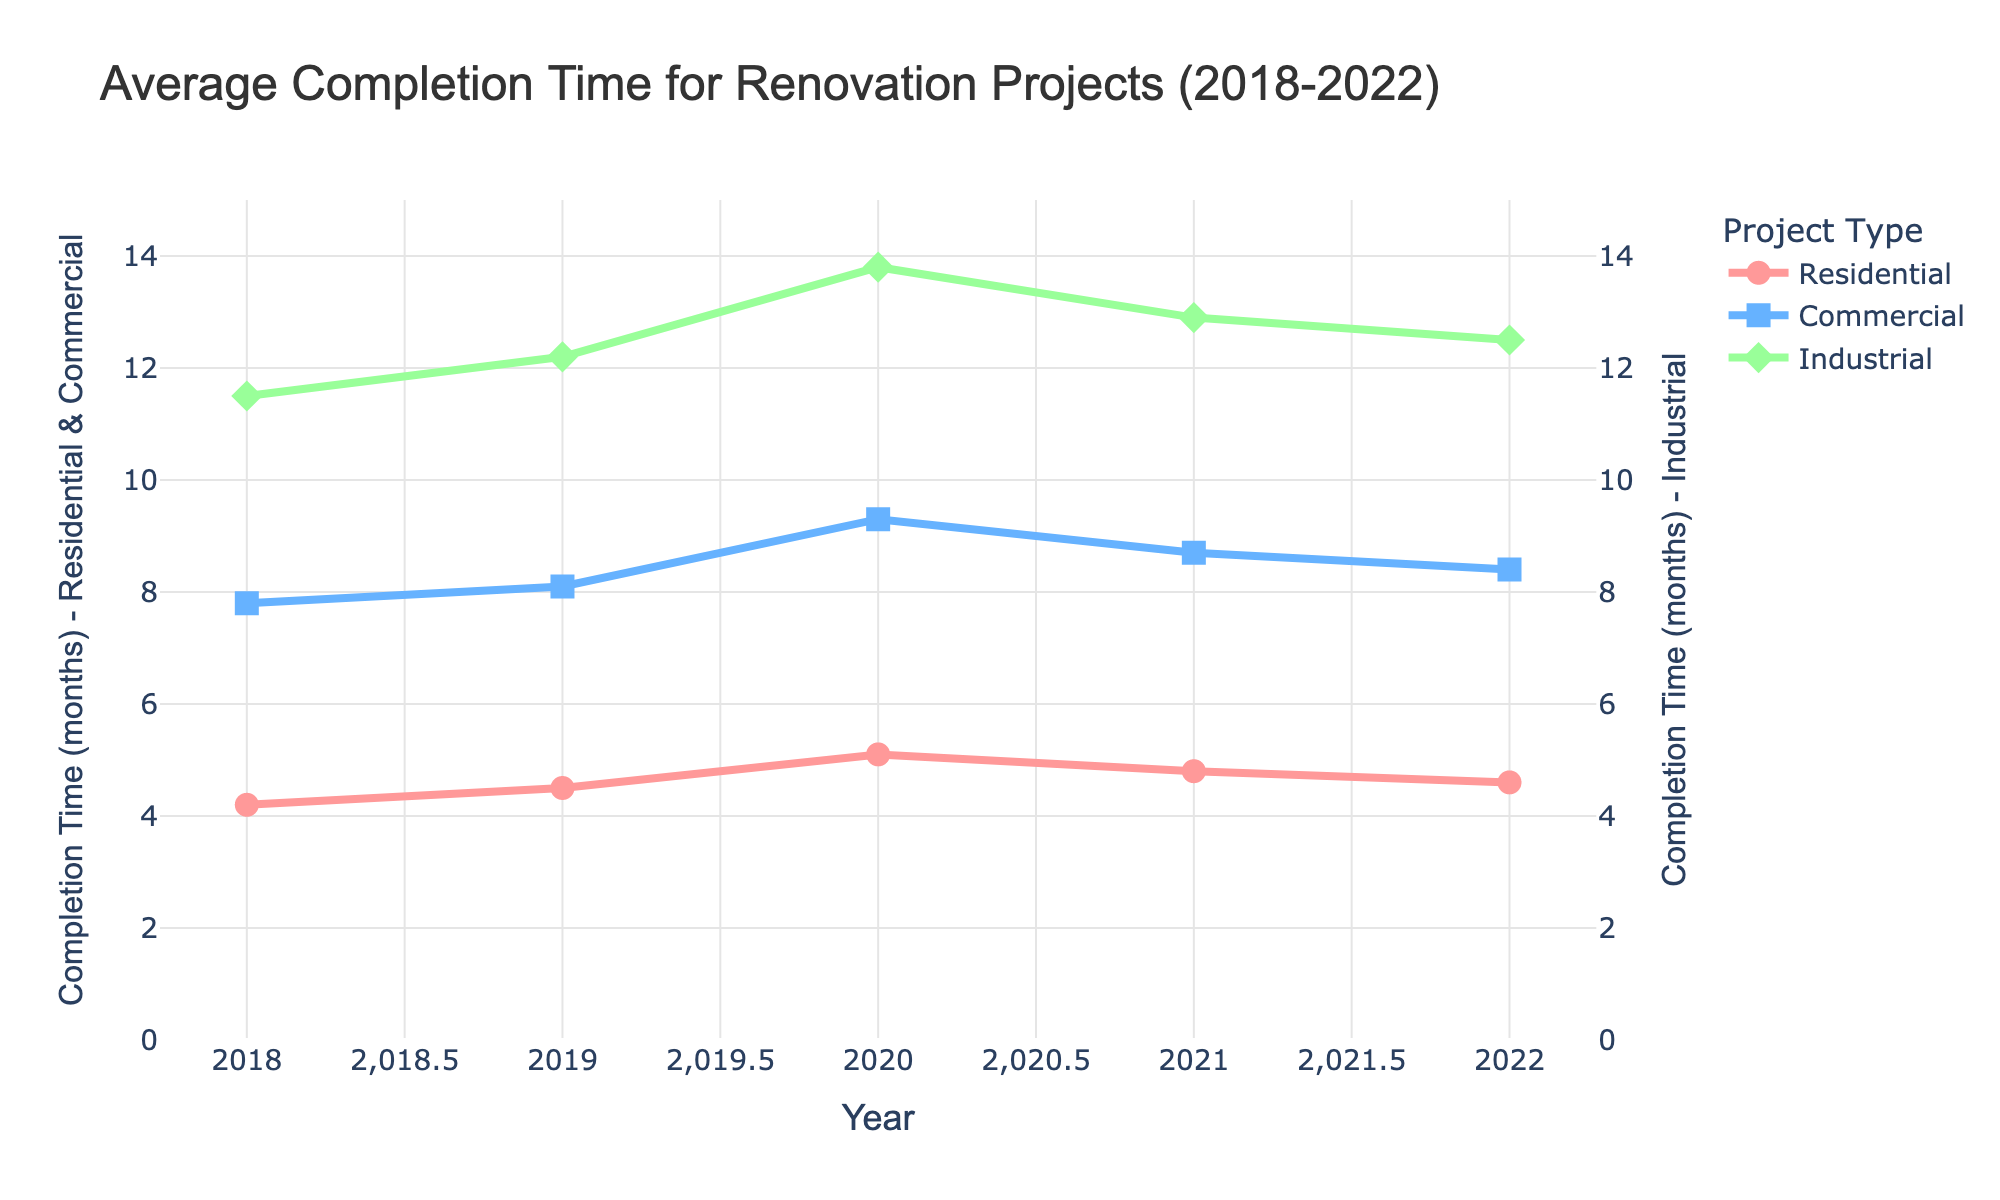What was the average completion time for residential projects in 2020? The residential completion time for 2020 is indicated by the red line. The value for 2020 is 5.1 months.
Answer: 5.1 months Which year had the highest completion time for commercial projects? The blue line represents commercial projects. The peak value is in 2020 with a completion time of 9.3 months.
Answer: 2020 Did the completion time for industrial projects increase or decrease from 2019 to 2020? The green line represents industrial projects. In 2019, the time is 12.2 months, and in 2020, it increased to 13.8 months.
Answer: Increase How did the completion time for residential projects change from 2020 to 2022, and by how much? The residential completion time decreased from 5.1 months in 2020 to 4.6 months in 2022. The change is 5.1 - 4.6 = 0.5 months.
Answer: Decreased by 0.5 months What is the overall trend in completion time for industrial projects over the 5-year period? The green line shows an increasing trend from 11.5 months in 2018 to 12.5 months in 2022.
Answer: Increasing trend In which year did residential and commercial projects have the same completion time, and what was the time? The red and blue lines intersect in 2021, both at 8.7 months.
Answer: 2021, 8.7 months What was the difference in completion time between commercial and industrial projects in 2019? Commercial projects were at 8.1 months and industrial projects at 12.2 months. The difference is 12.2 - 8.1 = 4.1 months.
Answer: 4.1 months Which project type saw the most consistent completion times over the 5 years? The residential projects saw the most consistent times, with values ranging narrowly between 4.2 to 5.1 months.
Answer: Residential What was the percentage increase in completion time for industrial projects from 2018 to 2020? Industrial projects went from 11.5 months in 2018 to 13.8 months in 2020. The increase is (13.8 - 11.5) / 11.5 * 100% = 20%.
Answer: 20% Identify the years when residential project completion times decreased. Residential projects had a decrease from 5.1 months in 2020 to 4.8 months in 2021, and again from 4.8 months in 2021 to 4.6 months in 2022.
Answer: 2021 and 2022 